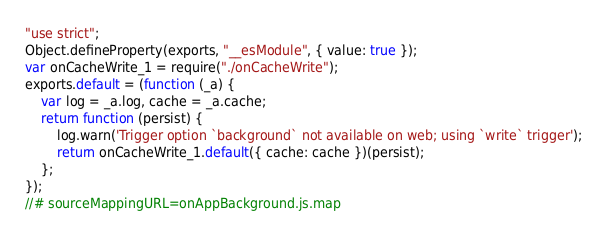Convert code to text. <code><loc_0><loc_0><loc_500><loc_500><_JavaScript_>"use strict";
Object.defineProperty(exports, "__esModule", { value: true });
var onCacheWrite_1 = require("./onCacheWrite");
exports.default = (function (_a) {
    var log = _a.log, cache = _a.cache;
    return function (persist) {
        log.warn('Trigger option `background` not available on web; using `write` trigger');
        return onCacheWrite_1.default({ cache: cache })(persist);
    };
});
//# sourceMappingURL=onAppBackground.js.map</code> 